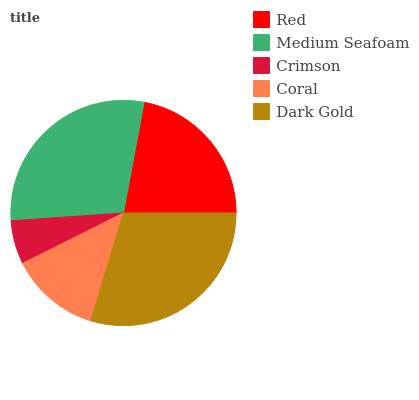Is Crimson the minimum?
Answer yes or no. Yes. Is Dark Gold the maximum?
Answer yes or no. Yes. Is Medium Seafoam the minimum?
Answer yes or no. No. Is Medium Seafoam the maximum?
Answer yes or no. No. Is Medium Seafoam greater than Red?
Answer yes or no. Yes. Is Red less than Medium Seafoam?
Answer yes or no. Yes. Is Red greater than Medium Seafoam?
Answer yes or no. No. Is Medium Seafoam less than Red?
Answer yes or no. No. Is Red the high median?
Answer yes or no. Yes. Is Red the low median?
Answer yes or no. Yes. Is Dark Gold the high median?
Answer yes or no. No. Is Dark Gold the low median?
Answer yes or no. No. 